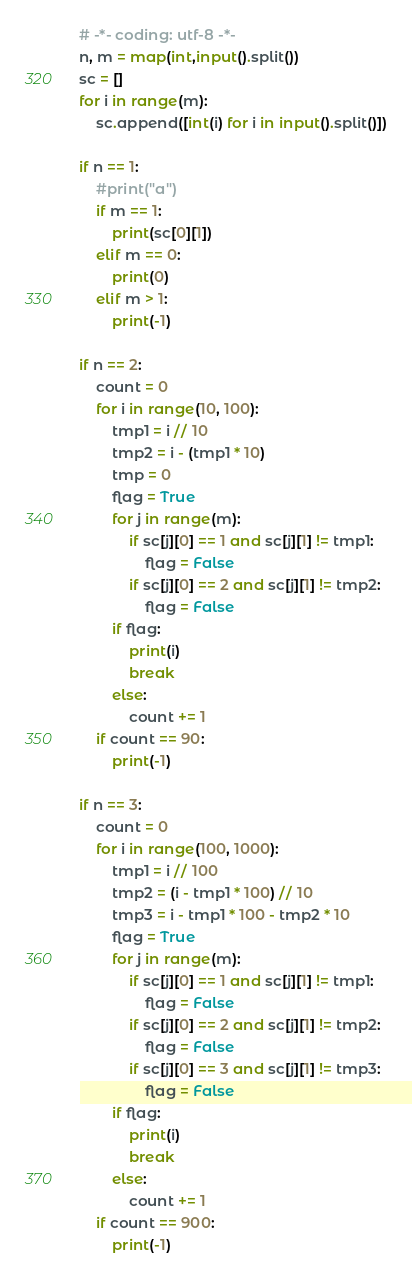Convert code to text. <code><loc_0><loc_0><loc_500><loc_500><_Python_># -*- coding: utf-8 -*-
n, m = map(int,input().split())
sc = []
for i in range(m):
    sc.append([int(i) for i in input().split()])

if n == 1:
    #print("a")
    if m == 1:
        print(sc[0][1])
    elif m == 0:
        print(0)
    elif m > 1:
        print(-1)

if n == 2:
    count = 0
    for i in range(10, 100):
        tmp1 = i // 10
        tmp2 = i - (tmp1 * 10)
        tmp = 0
        flag = True
        for j in range(m):
            if sc[j][0] == 1 and sc[j][1] != tmp1:
                flag = False
            if sc[j][0] == 2 and sc[j][1] != tmp2:
                flag = False
        if flag:
            print(i)
            break
        else:
            count += 1
    if count == 90:
        print(-1)

if n == 3:
    count = 0
    for i in range(100, 1000):
        tmp1 = i // 100
        tmp2 = (i - tmp1 * 100) // 10
        tmp3 = i - tmp1 * 100 - tmp2 * 10
        flag = True
        for j in range(m):
            if sc[j][0] == 1 and sc[j][1] != tmp1:
                flag = False
            if sc[j][0] == 2 and sc[j][1] != tmp2:
                flag = False
            if sc[j][0] == 3 and sc[j][1] != tmp3:
                flag = False
        if flag:
            print(i)
            break
        else:
            count += 1
    if count == 900:
        print(-1)</code> 